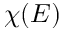<formula> <loc_0><loc_0><loc_500><loc_500>\chi ( E )</formula> 